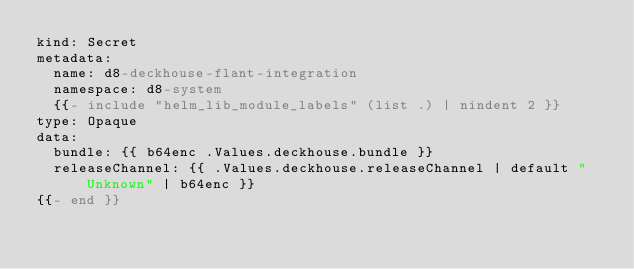Convert code to text. <code><loc_0><loc_0><loc_500><loc_500><_YAML_>kind: Secret
metadata:
  name: d8-deckhouse-flant-integration
  namespace: d8-system
  {{- include "helm_lib_module_labels" (list .) | nindent 2 }}
type: Opaque
data:
  bundle: {{ b64enc .Values.deckhouse.bundle }}
  releaseChannel: {{ .Values.deckhouse.releaseChannel | default "Unknown" | b64enc }}
{{- end }}
</code> 